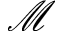<formula> <loc_0><loc_0><loc_500><loc_500>\mathcal { M }</formula> 